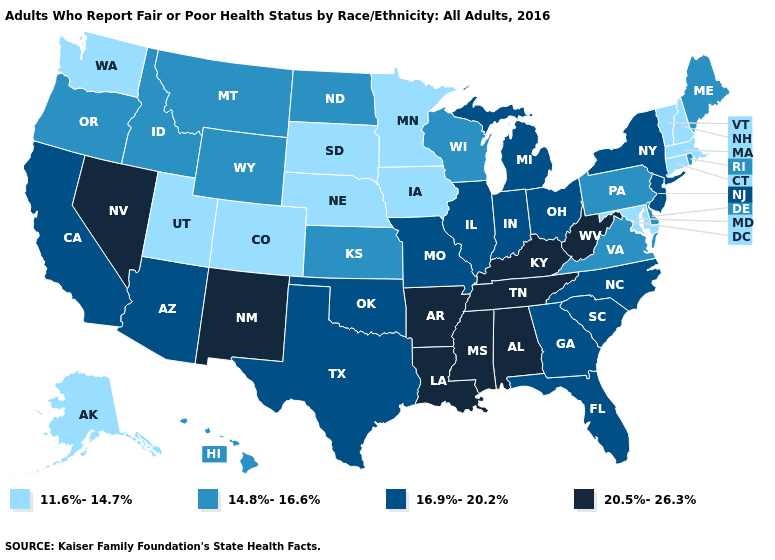What is the highest value in states that border Montana?
Write a very short answer. 14.8%-16.6%. What is the value of Michigan?
Concise answer only. 16.9%-20.2%. Does New Jersey have the lowest value in the Northeast?
Quick response, please. No. What is the highest value in the USA?
Give a very brief answer. 20.5%-26.3%. Name the states that have a value in the range 16.9%-20.2%?
Quick response, please. Arizona, California, Florida, Georgia, Illinois, Indiana, Michigan, Missouri, New Jersey, New York, North Carolina, Ohio, Oklahoma, South Carolina, Texas. What is the value of Alaska?
Quick response, please. 11.6%-14.7%. Name the states that have a value in the range 20.5%-26.3%?
Short answer required. Alabama, Arkansas, Kentucky, Louisiana, Mississippi, Nevada, New Mexico, Tennessee, West Virginia. Among the states that border Tennessee , does Mississippi have the lowest value?
Keep it brief. No. Does Michigan have a higher value than Oregon?
Quick response, please. Yes. Name the states that have a value in the range 20.5%-26.3%?
Be succinct. Alabama, Arkansas, Kentucky, Louisiana, Mississippi, Nevada, New Mexico, Tennessee, West Virginia. Which states have the highest value in the USA?
Answer briefly. Alabama, Arkansas, Kentucky, Louisiana, Mississippi, Nevada, New Mexico, Tennessee, West Virginia. Name the states that have a value in the range 14.8%-16.6%?
Give a very brief answer. Delaware, Hawaii, Idaho, Kansas, Maine, Montana, North Dakota, Oregon, Pennsylvania, Rhode Island, Virginia, Wisconsin, Wyoming. Among the states that border Washington , which have the lowest value?
Be succinct. Idaho, Oregon. Among the states that border Montana , which have the highest value?
Quick response, please. Idaho, North Dakota, Wyoming. What is the value of Oregon?
Keep it brief. 14.8%-16.6%. 